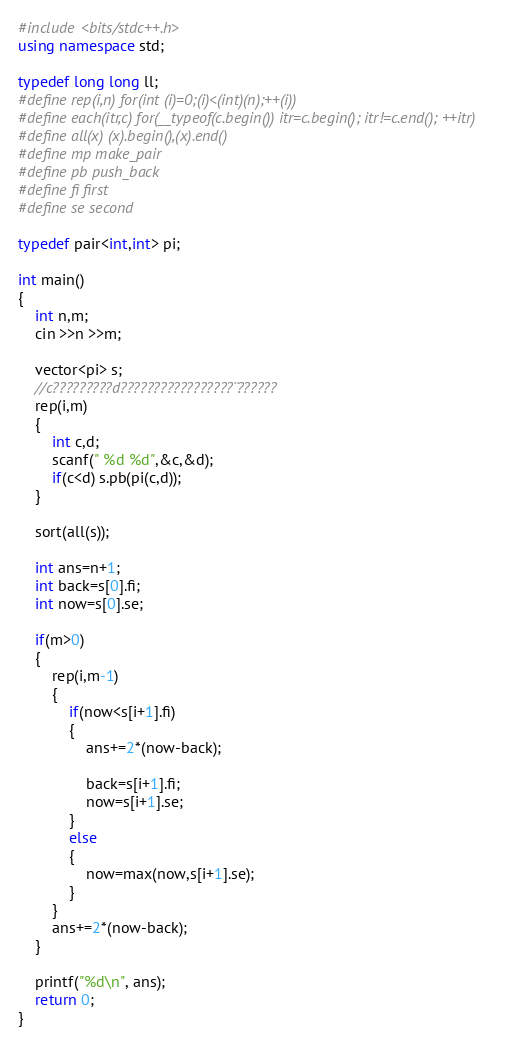<code> <loc_0><loc_0><loc_500><loc_500><_C++_>#include <bits/stdc++.h>
using namespace std;

typedef long long ll;
#define rep(i,n) for(int (i)=0;(i)<(int)(n);++(i))
#define each(itr,c) for(__typeof(c.begin()) itr=c.begin(); itr!=c.end(); ++itr)
#define all(x) (x).begin(),(x).end()
#define mp make_pair
#define pb push_back
#define fi first
#define se second

typedef pair<int,int> pi;

int main()
{
    int n,m;
    cin >>n >>m;

    vector<pi> s;
    //c?????????d?????????????????¨??????
    rep(i,m)
    {
        int c,d;
        scanf(" %d %d",&c,&d);
        if(c<d) s.pb(pi(c,d));
    }

    sort(all(s));

    int ans=n+1;
    int back=s[0].fi;
    int now=s[0].se;

    if(m>0)
    {
        rep(i,m-1)
        {
            if(now<s[i+1].fi)
            {
                ans+=2*(now-back);

                back=s[i+1].fi;
                now=s[i+1].se;
            }
            else
            {
                now=max(now,s[i+1].se);
            }
        }
        ans+=2*(now-back);
    }

    printf("%d\n", ans);
    return 0;
}</code> 